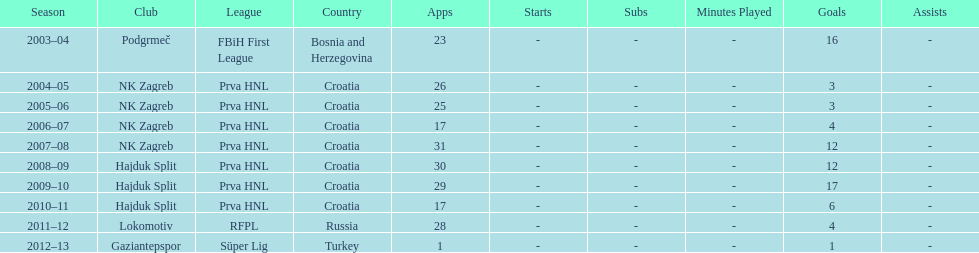The team with the most goals Hajduk Split. 